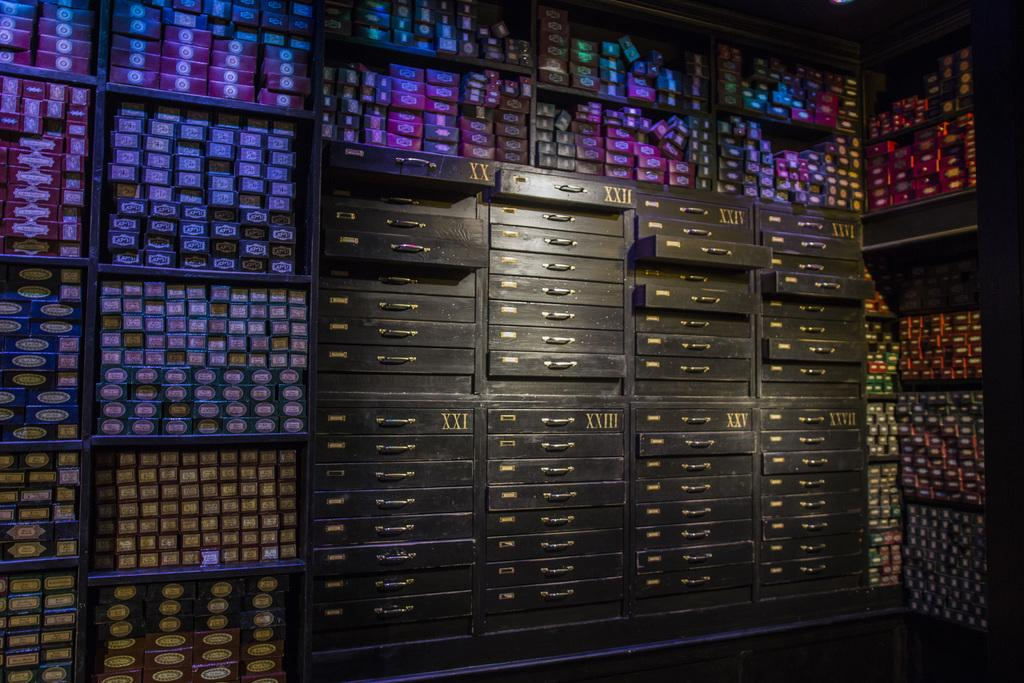What type of storage units are present in the image? There are drawers and boxes in the image. How are the drawers and boxes arranged in the image? The drawers and boxes are on racks in the image. How much money is stored in the drawers and boxes in the image? There is no indication of money being stored in the drawers or boxes in the image. 